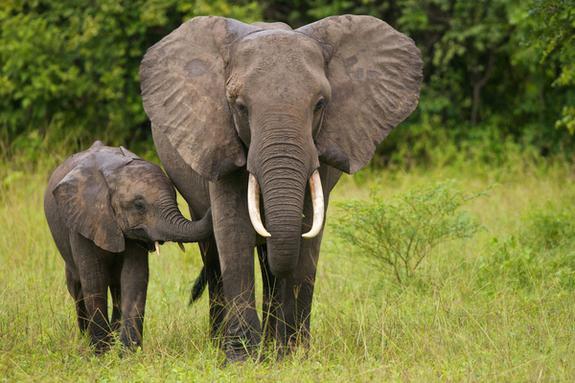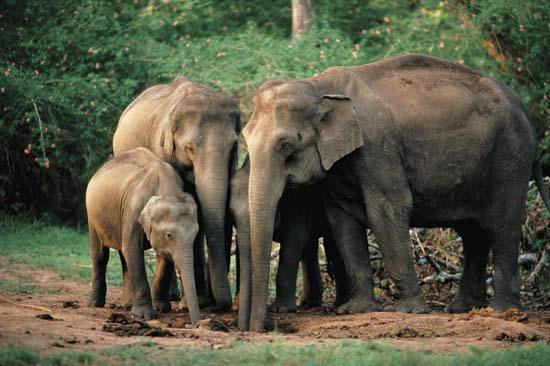The first image is the image on the left, the second image is the image on the right. Considering the images on both sides, is "In one image, and elephant with tusks has its ears fanned out their full width." valid? Answer yes or no. Yes. 